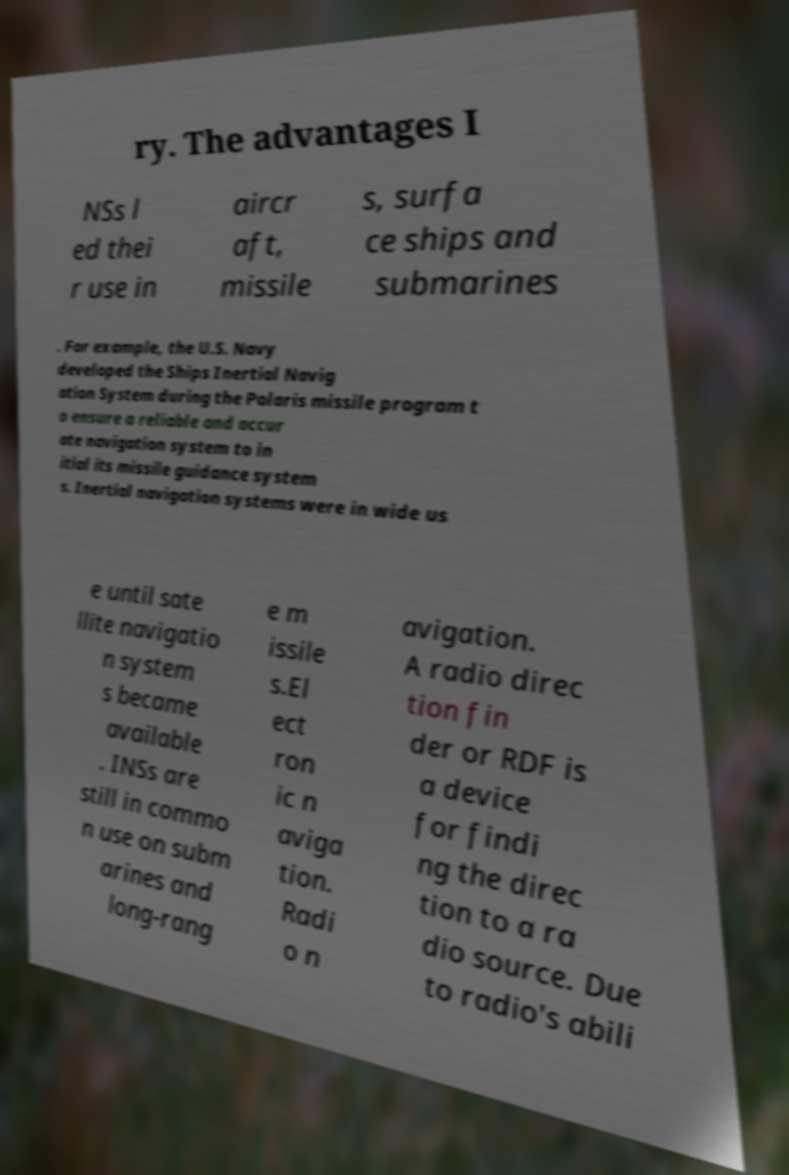Please read and relay the text visible in this image. What does it say? ry. The advantages I NSs l ed thei r use in aircr aft, missile s, surfa ce ships and submarines . For example, the U.S. Navy developed the Ships Inertial Navig ation System during the Polaris missile program t o ensure a reliable and accur ate navigation system to in itial its missile guidance system s. Inertial navigation systems were in wide us e until sate llite navigatio n system s became available . INSs are still in commo n use on subm arines and long-rang e m issile s.El ect ron ic n aviga tion. Radi o n avigation. A radio direc tion fin der or RDF is a device for findi ng the direc tion to a ra dio source. Due to radio's abili 